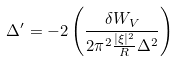Convert formula to latex. <formula><loc_0><loc_0><loc_500><loc_500>\Delta ^ { \prime } = - 2 \left ( \frac { \delta W _ { V } } { 2 \pi ^ { 2 } \frac { | \xi | ^ { 2 } } { R } \Delta ^ { 2 } } \right )</formula> 